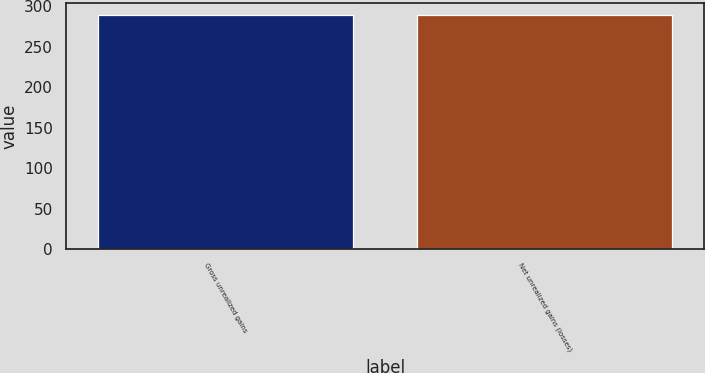<chart> <loc_0><loc_0><loc_500><loc_500><bar_chart><fcel>Gross unrealized gains<fcel>Net unrealized gains (losses)<nl><fcel>289<fcel>289.1<nl></chart> 